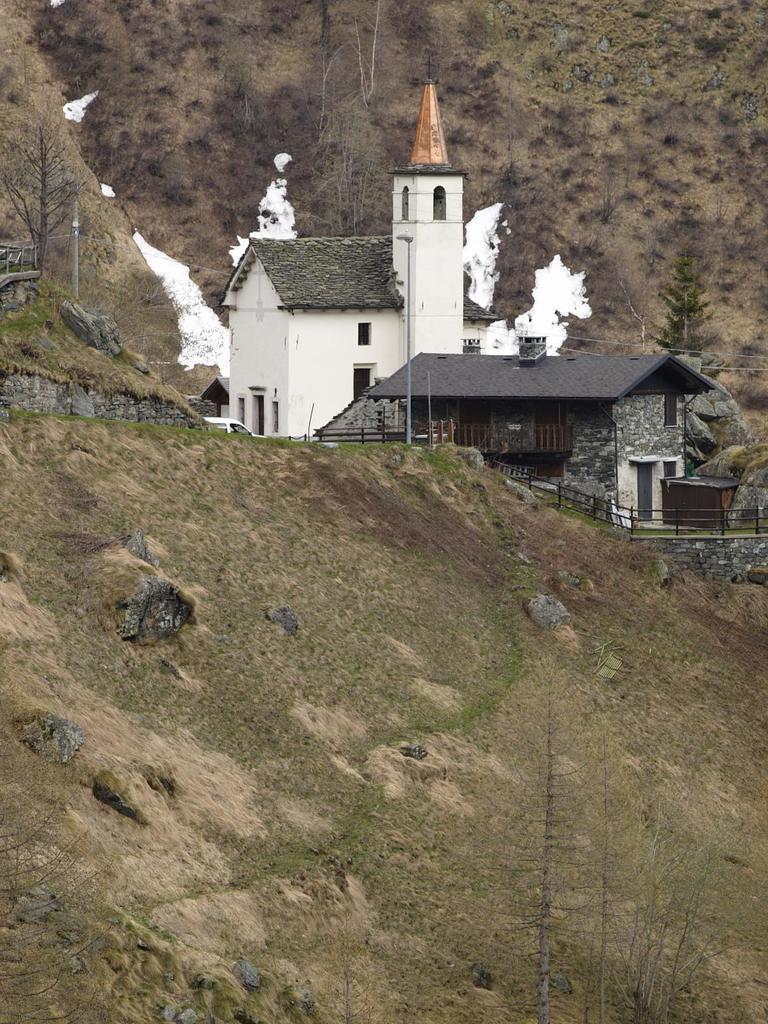Describe this image in one or two sentences. Here we can see houses, fence, grass and trees. 